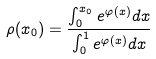<formula> <loc_0><loc_0><loc_500><loc_500>\rho ( x _ { 0 } ) = \frac { \int _ { 0 } ^ { x _ { 0 } } e ^ { \varphi ( x ) } d x } { \int _ { 0 } ^ { 1 } e ^ { \varphi ( x ) } d x }</formula> 